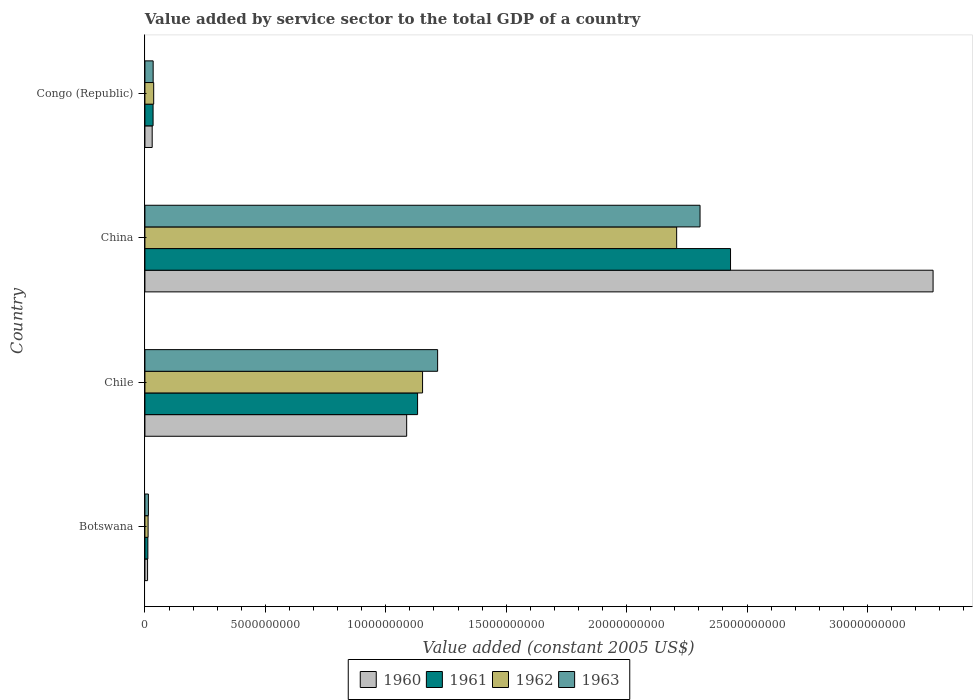Are the number of bars on each tick of the Y-axis equal?
Make the answer very short. Yes. How many bars are there on the 4th tick from the top?
Your answer should be compact. 4. How many bars are there on the 4th tick from the bottom?
Your answer should be compact. 4. What is the label of the 4th group of bars from the top?
Make the answer very short. Botswana. What is the value added by service sector in 1962 in Chile?
Make the answer very short. 1.15e+1. Across all countries, what is the maximum value added by service sector in 1962?
Ensure brevity in your answer.  2.21e+1. Across all countries, what is the minimum value added by service sector in 1961?
Your answer should be very brief. 1.22e+08. In which country was the value added by service sector in 1960 minimum?
Ensure brevity in your answer.  Botswana. What is the total value added by service sector in 1963 in the graph?
Provide a short and direct response. 3.57e+1. What is the difference between the value added by service sector in 1961 in China and that in Congo (Republic)?
Your response must be concise. 2.40e+1. What is the difference between the value added by service sector in 1963 in Botswana and the value added by service sector in 1962 in China?
Ensure brevity in your answer.  -2.19e+1. What is the average value added by service sector in 1962 per country?
Ensure brevity in your answer.  8.52e+09. What is the difference between the value added by service sector in 1962 and value added by service sector in 1963 in Botswana?
Provide a short and direct response. -1.28e+07. In how many countries, is the value added by service sector in 1963 greater than 25000000000 US$?
Your response must be concise. 0. What is the ratio of the value added by service sector in 1963 in Chile to that in China?
Keep it short and to the point. 0.53. Is the value added by service sector in 1963 in Chile less than that in China?
Ensure brevity in your answer.  Yes. Is the difference between the value added by service sector in 1962 in Botswana and China greater than the difference between the value added by service sector in 1963 in Botswana and China?
Offer a very short reply. Yes. What is the difference between the highest and the second highest value added by service sector in 1962?
Ensure brevity in your answer.  1.05e+1. What is the difference between the highest and the lowest value added by service sector in 1963?
Provide a succinct answer. 2.29e+1. Is the sum of the value added by service sector in 1963 in Chile and China greater than the maximum value added by service sector in 1961 across all countries?
Make the answer very short. Yes. How many bars are there?
Ensure brevity in your answer.  16. Are all the bars in the graph horizontal?
Offer a very short reply. Yes. How many countries are there in the graph?
Your response must be concise. 4. Does the graph contain any zero values?
Provide a succinct answer. No. Does the graph contain grids?
Provide a short and direct response. No. What is the title of the graph?
Give a very brief answer. Value added by service sector to the total GDP of a country. What is the label or title of the X-axis?
Your answer should be very brief. Value added (constant 2005 US$). What is the Value added (constant 2005 US$) of 1960 in Botswana?
Provide a succinct answer. 1.11e+08. What is the Value added (constant 2005 US$) of 1961 in Botswana?
Make the answer very short. 1.22e+08. What is the Value added (constant 2005 US$) of 1962 in Botswana?
Keep it short and to the point. 1.32e+08. What is the Value added (constant 2005 US$) of 1963 in Botswana?
Provide a short and direct response. 1.45e+08. What is the Value added (constant 2005 US$) in 1960 in Chile?
Offer a very short reply. 1.09e+1. What is the Value added (constant 2005 US$) in 1961 in Chile?
Ensure brevity in your answer.  1.13e+1. What is the Value added (constant 2005 US$) in 1962 in Chile?
Your response must be concise. 1.15e+1. What is the Value added (constant 2005 US$) of 1963 in Chile?
Offer a very short reply. 1.22e+1. What is the Value added (constant 2005 US$) in 1960 in China?
Your answer should be compact. 3.27e+1. What is the Value added (constant 2005 US$) in 1961 in China?
Provide a succinct answer. 2.43e+1. What is the Value added (constant 2005 US$) of 1962 in China?
Your answer should be very brief. 2.21e+1. What is the Value added (constant 2005 US$) of 1963 in China?
Provide a short and direct response. 2.30e+1. What is the Value added (constant 2005 US$) in 1960 in Congo (Republic)?
Your answer should be very brief. 3.02e+08. What is the Value added (constant 2005 US$) in 1961 in Congo (Republic)?
Your answer should be compact. 3.39e+08. What is the Value added (constant 2005 US$) of 1962 in Congo (Republic)?
Offer a terse response. 3.64e+08. What is the Value added (constant 2005 US$) of 1963 in Congo (Republic)?
Give a very brief answer. 3.42e+08. Across all countries, what is the maximum Value added (constant 2005 US$) of 1960?
Keep it short and to the point. 3.27e+1. Across all countries, what is the maximum Value added (constant 2005 US$) of 1961?
Offer a very short reply. 2.43e+1. Across all countries, what is the maximum Value added (constant 2005 US$) of 1962?
Your response must be concise. 2.21e+1. Across all countries, what is the maximum Value added (constant 2005 US$) of 1963?
Offer a very short reply. 2.30e+1. Across all countries, what is the minimum Value added (constant 2005 US$) in 1960?
Provide a succinct answer. 1.11e+08. Across all countries, what is the minimum Value added (constant 2005 US$) of 1961?
Offer a very short reply. 1.22e+08. Across all countries, what is the minimum Value added (constant 2005 US$) in 1962?
Make the answer very short. 1.32e+08. Across all countries, what is the minimum Value added (constant 2005 US$) in 1963?
Give a very brief answer. 1.45e+08. What is the total Value added (constant 2005 US$) in 1960 in the graph?
Your response must be concise. 4.40e+1. What is the total Value added (constant 2005 US$) in 1961 in the graph?
Provide a short and direct response. 3.61e+1. What is the total Value added (constant 2005 US$) in 1962 in the graph?
Offer a very short reply. 3.41e+1. What is the total Value added (constant 2005 US$) of 1963 in the graph?
Your answer should be very brief. 3.57e+1. What is the difference between the Value added (constant 2005 US$) in 1960 in Botswana and that in Chile?
Your answer should be compact. -1.08e+1. What is the difference between the Value added (constant 2005 US$) in 1961 in Botswana and that in Chile?
Your answer should be compact. -1.12e+1. What is the difference between the Value added (constant 2005 US$) of 1962 in Botswana and that in Chile?
Your answer should be very brief. -1.14e+1. What is the difference between the Value added (constant 2005 US$) in 1963 in Botswana and that in Chile?
Make the answer very short. -1.20e+1. What is the difference between the Value added (constant 2005 US$) of 1960 in Botswana and that in China?
Provide a short and direct response. -3.26e+1. What is the difference between the Value added (constant 2005 US$) of 1961 in Botswana and that in China?
Give a very brief answer. -2.42e+1. What is the difference between the Value added (constant 2005 US$) in 1962 in Botswana and that in China?
Provide a succinct answer. -2.19e+1. What is the difference between the Value added (constant 2005 US$) in 1963 in Botswana and that in China?
Provide a short and direct response. -2.29e+1. What is the difference between the Value added (constant 2005 US$) of 1960 in Botswana and that in Congo (Republic)?
Keep it short and to the point. -1.91e+08. What is the difference between the Value added (constant 2005 US$) in 1961 in Botswana and that in Congo (Republic)?
Provide a succinct answer. -2.17e+08. What is the difference between the Value added (constant 2005 US$) of 1962 in Botswana and that in Congo (Republic)?
Ensure brevity in your answer.  -2.32e+08. What is the difference between the Value added (constant 2005 US$) in 1963 in Botswana and that in Congo (Republic)?
Offer a terse response. -1.97e+08. What is the difference between the Value added (constant 2005 US$) in 1960 in Chile and that in China?
Make the answer very short. -2.19e+1. What is the difference between the Value added (constant 2005 US$) of 1961 in Chile and that in China?
Your answer should be very brief. -1.30e+1. What is the difference between the Value added (constant 2005 US$) in 1962 in Chile and that in China?
Your answer should be compact. -1.05e+1. What is the difference between the Value added (constant 2005 US$) of 1963 in Chile and that in China?
Your response must be concise. -1.09e+1. What is the difference between the Value added (constant 2005 US$) of 1960 in Chile and that in Congo (Republic)?
Make the answer very short. 1.06e+1. What is the difference between the Value added (constant 2005 US$) in 1961 in Chile and that in Congo (Republic)?
Your answer should be very brief. 1.10e+1. What is the difference between the Value added (constant 2005 US$) of 1962 in Chile and that in Congo (Republic)?
Provide a short and direct response. 1.12e+1. What is the difference between the Value added (constant 2005 US$) of 1963 in Chile and that in Congo (Republic)?
Keep it short and to the point. 1.18e+1. What is the difference between the Value added (constant 2005 US$) in 1960 in China and that in Congo (Republic)?
Make the answer very short. 3.24e+1. What is the difference between the Value added (constant 2005 US$) of 1961 in China and that in Congo (Republic)?
Your answer should be very brief. 2.40e+1. What is the difference between the Value added (constant 2005 US$) in 1962 in China and that in Congo (Republic)?
Your answer should be very brief. 2.17e+1. What is the difference between the Value added (constant 2005 US$) of 1963 in China and that in Congo (Republic)?
Ensure brevity in your answer.  2.27e+1. What is the difference between the Value added (constant 2005 US$) of 1960 in Botswana and the Value added (constant 2005 US$) of 1961 in Chile?
Your answer should be compact. -1.12e+1. What is the difference between the Value added (constant 2005 US$) in 1960 in Botswana and the Value added (constant 2005 US$) in 1962 in Chile?
Your answer should be very brief. -1.14e+1. What is the difference between the Value added (constant 2005 US$) of 1960 in Botswana and the Value added (constant 2005 US$) of 1963 in Chile?
Ensure brevity in your answer.  -1.20e+1. What is the difference between the Value added (constant 2005 US$) of 1961 in Botswana and the Value added (constant 2005 US$) of 1962 in Chile?
Offer a very short reply. -1.14e+1. What is the difference between the Value added (constant 2005 US$) of 1961 in Botswana and the Value added (constant 2005 US$) of 1963 in Chile?
Your response must be concise. -1.20e+1. What is the difference between the Value added (constant 2005 US$) in 1962 in Botswana and the Value added (constant 2005 US$) in 1963 in Chile?
Ensure brevity in your answer.  -1.20e+1. What is the difference between the Value added (constant 2005 US$) in 1960 in Botswana and the Value added (constant 2005 US$) in 1961 in China?
Ensure brevity in your answer.  -2.42e+1. What is the difference between the Value added (constant 2005 US$) in 1960 in Botswana and the Value added (constant 2005 US$) in 1962 in China?
Your answer should be very brief. -2.20e+1. What is the difference between the Value added (constant 2005 US$) in 1960 in Botswana and the Value added (constant 2005 US$) in 1963 in China?
Make the answer very short. -2.29e+1. What is the difference between the Value added (constant 2005 US$) of 1961 in Botswana and the Value added (constant 2005 US$) of 1962 in China?
Give a very brief answer. -2.20e+1. What is the difference between the Value added (constant 2005 US$) of 1961 in Botswana and the Value added (constant 2005 US$) of 1963 in China?
Your response must be concise. -2.29e+1. What is the difference between the Value added (constant 2005 US$) in 1962 in Botswana and the Value added (constant 2005 US$) in 1963 in China?
Give a very brief answer. -2.29e+1. What is the difference between the Value added (constant 2005 US$) of 1960 in Botswana and the Value added (constant 2005 US$) of 1961 in Congo (Republic)?
Give a very brief answer. -2.28e+08. What is the difference between the Value added (constant 2005 US$) in 1960 in Botswana and the Value added (constant 2005 US$) in 1962 in Congo (Republic)?
Provide a succinct answer. -2.53e+08. What is the difference between the Value added (constant 2005 US$) in 1960 in Botswana and the Value added (constant 2005 US$) in 1963 in Congo (Republic)?
Your answer should be very brief. -2.31e+08. What is the difference between the Value added (constant 2005 US$) in 1961 in Botswana and the Value added (constant 2005 US$) in 1962 in Congo (Republic)?
Keep it short and to the point. -2.42e+08. What is the difference between the Value added (constant 2005 US$) in 1961 in Botswana and the Value added (constant 2005 US$) in 1963 in Congo (Republic)?
Your answer should be very brief. -2.20e+08. What is the difference between the Value added (constant 2005 US$) of 1962 in Botswana and the Value added (constant 2005 US$) of 1963 in Congo (Republic)?
Provide a succinct answer. -2.10e+08. What is the difference between the Value added (constant 2005 US$) of 1960 in Chile and the Value added (constant 2005 US$) of 1961 in China?
Your response must be concise. -1.34e+1. What is the difference between the Value added (constant 2005 US$) in 1960 in Chile and the Value added (constant 2005 US$) in 1962 in China?
Keep it short and to the point. -1.12e+1. What is the difference between the Value added (constant 2005 US$) in 1960 in Chile and the Value added (constant 2005 US$) in 1963 in China?
Your answer should be very brief. -1.22e+1. What is the difference between the Value added (constant 2005 US$) of 1961 in Chile and the Value added (constant 2005 US$) of 1962 in China?
Keep it short and to the point. -1.08e+1. What is the difference between the Value added (constant 2005 US$) of 1961 in Chile and the Value added (constant 2005 US$) of 1963 in China?
Your answer should be compact. -1.17e+1. What is the difference between the Value added (constant 2005 US$) of 1962 in Chile and the Value added (constant 2005 US$) of 1963 in China?
Give a very brief answer. -1.15e+1. What is the difference between the Value added (constant 2005 US$) in 1960 in Chile and the Value added (constant 2005 US$) in 1961 in Congo (Republic)?
Offer a terse response. 1.05e+1. What is the difference between the Value added (constant 2005 US$) in 1960 in Chile and the Value added (constant 2005 US$) in 1962 in Congo (Republic)?
Provide a short and direct response. 1.05e+1. What is the difference between the Value added (constant 2005 US$) of 1960 in Chile and the Value added (constant 2005 US$) of 1963 in Congo (Republic)?
Your response must be concise. 1.05e+1. What is the difference between the Value added (constant 2005 US$) of 1961 in Chile and the Value added (constant 2005 US$) of 1962 in Congo (Republic)?
Make the answer very short. 1.10e+1. What is the difference between the Value added (constant 2005 US$) of 1961 in Chile and the Value added (constant 2005 US$) of 1963 in Congo (Republic)?
Provide a short and direct response. 1.10e+1. What is the difference between the Value added (constant 2005 US$) in 1962 in Chile and the Value added (constant 2005 US$) in 1963 in Congo (Republic)?
Offer a terse response. 1.12e+1. What is the difference between the Value added (constant 2005 US$) of 1960 in China and the Value added (constant 2005 US$) of 1961 in Congo (Republic)?
Your response must be concise. 3.24e+1. What is the difference between the Value added (constant 2005 US$) in 1960 in China and the Value added (constant 2005 US$) in 1962 in Congo (Republic)?
Offer a terse response. 3.24e+1. What is the difference between the Value added (constant 2005 US$) of 1960 in China and the Value added (constant 2005 US$) of 1963 in Congo (Republic)?
Ensure brevity in your answer.  3.24e+1. What is the difference between the Value added (constant 2005 US$) in 1961 in China and the Value added (constant 2005 US$) in 1962 in Congo (Republic)?
Offer a terse response. 2.39e+1. What is the difference between the Value added (constant 2005 US$) of 1961 in China and the Value added (constant 2005 US$) of 1963 in Congo (Republic)?
Ensure brevity in your answer.  2.40e+1. What is the difference between the Value added (constant 2005 US$) in 1962 in China and the Value added (constant 2005 US$) in 1963 in Congo (Republic)?
Your answer should be compact. 2.17e+1. What is the average Value added (constant 2005 US$) of 1960 per country?
Provide a short and direct response. 1.10e+1. What is the average Value added (constant 2005 US$) in 1961 per country?
Your answer should be very brief. 9.02e+09. What is the average Value added (constant 2005 US$) in 1962 per country?
Your answer should be compact. 8.52e+09. What is the average Value added (constant 2005 US$) in 1963 per country?
Your answer should be very brief. 8.92e+09. What is the difference between the Value added (constant 2005 US$) of 1960 and Value added (constant 2005 US$) of 1961 in Botswana?
Your answer should be very brief. -1.12e+07. What is the difference between the Value added (constant 2005 US$) in 1960 and Value added (constant 2005 US$) in 1962 in Botswana?
Offer a terse response. -2.17e+07. What is the difference between the Value added (constant 2005 US$) in 1960 and Value added (constant 2005 US$) in 1963 in Botswana?
Give a very brief answer. -3.45e+07. What is the difference between the Value added (constant 2005 US$) of 1961 and Value added (constant 2005 US$) of 1962 in Botswana?
Offer a terse response. -1.05e+07. What is the difference between the Value added (constant 2005 US$) in 1961 and Value added (constant 2005 US$) in 1963 in Botswana?
Keep it short and to the point. -2.33e+07. What is the difference between the Value added (constant 2005 US$) in 1962 and Value added (constant 2005 US$) in 1963 in Botswana?
Provide a succinct answer. -1.28e+07. What is the difference between the Value added (constant 2005 US$) of 1960 and Value added (constant 2005 US$) of 1961 in Chile?
Offer a very short reply. -4.53e+08. What is the difference between the Value added (constant 2005 US$) in 1960 and Value added (constant 2005 US$) in 1962 in Chile?
Give a very brief answer. -6.60e+08. What is the difference between the Value added (constant 2005 US$) of 1960 and Value added (constant 2005 US$) of 1963 in Chile?
Provide a short and direct response. -1.29e+09. What is the difference between the Value added (constant 2005 US$) in 1961 and Value added (constant 2005 US$) in 1962 in Chile?
Provide a succinct answer. -2.07e+08. What is the difference between the Value added (constant 2005 US$) in 1961 and Value added (constant 2005 US$) in 1963 in Chile?
Provide a short and direct response. -8.32e+08. What is the difference between the Value added (constant 2005 US$) of 1962 and Value added (constant 2005 US$) of 1963 in Chile?
Keep it short and to the point. -6.25e+08. What is the difference between the Value added (constant 2005 US$) in 1960 and Value added (constant 2005 US$) in 1961 in China?
Offer a very short reply. 8.41e+09. What is the difference between the Value added (constant 2005 US$) in 1960 and Value added (constant 2005 US$) in 1962 in China?
Provide a succinct answer. 1.06e+1. What is the difference between the Value added (constant 2005 US$) of 1960 and Value added (constant 2005 US$) of 1963 in China?
Your answer should be compact. 9.68e+09. What is the difference between the Value added (constant 2005 US$) in 1961 and Value added (constant 2005 US$) in 1962 in China?
Provide a short and direct response. 2.24e+09. What is the difference between the Value added (constant 2005 US$) of 1961 and Value added (constant 2005 US$) of 1963 in China?
Keep it short and to the point. 1.27e+09. What is the difference between the Value added (constant 2005 US$) in 1962 and Value added (constant 2005 US$) in 1963 in China?
Your answer should be very brief. -9.71e+08. What is the difference between the Value added (constant 2005 US$) of 1960 and Value added (constant 2005 US$) of 1961 in Congo (Republic)?
Give a very brief answer. -3.74e+07. What is the difference between the Value added (constant 2005 US$) in 1960 and Value added (constant 2005 US$) in 1962 in Congo (Republic)?
Give a very brief answer. -6.23e+07. What is the difference between the Value added (constant 2005 US$) of 1960 and Value added (constant 2005 US$) of 1963 in Congo (Republic)?
Your response must be concise. -4.05e+07. What is the difference between the Value added (constant 2005 US$) in 1961 and Value added (constant 2005 US$) in 1962 in Congo (Republic)?
Ensure brevity in your answer.  -2.49e+07. What is the difference between the Value added (constant 2005 US$) of 1961 and Value added (constant 2005 US$) of 1963 in Congo (Republic)?
Provide a short and direct response. -3.09e+06. What is the difference between the Value added (constant 2005 US$) in 1962 and Value added (constant 2005 US$) in 1963 in Congo (Republic)?
Ensure brevity in your answer.  2.18e+07. What is the ratio of the Value added (constant 2005 US$) in 1960 in Botswana to that in Chile?
Your response must be concise. 0.01. What is the ratio of the Value added (constant 2005 US$) in 1961 in Botswana to that in Chile?
Ensure brevity in your answer.  0.01. What is the ratio of the Value added (constant 2005 US$) in 1962 in Botswana to that in Chile?
Make the answer very short. 0.01. What is the ratio of the Value added (constant 2005 US$) in 1963 in Botswana to that in Chile?
Offer a terse response. 0.01. What is the ratio of the Value added (constant 2005 US$) of 1960 in Botswana to that in China?
Your answer should be very brief. 0. What is the ratio of the Value added (constant 2005 US$) in 1961 in Botswana to that in China?
Offer a very short reply. 0.01. What is the ratio of the Value added (constant 2005 US$) in 1962 in Botswana to that in China?
Your response must be concise. 0.01. What is the ratio of the Value added (constant 2005 US$) in 1963 in Botswana to that in China?
Offer a very short reply. 0.01. What is the ratio of the Value added (constant 2005 US$) in 1960 in Botswana to that in Congo (Republic)?
Offer a very short reply. 0.37. What is the ratio of the Value added (constant 2005 US$) in 1961 in Botswana to that in Congo (Republic)?
Provide a succinct answer. 0.36. What is the ratio of the Value added (constant 2005 US$) in 1962 in Botswana to that in Congo (Republic)?
Your response must be concise. 0.36. What is the ratio of the Value added (constant 2005 US$) in 1963 in Botswana to that in Congo (Republic)?
Ensure brevity in your answer.  0.42. What is the ratio of the Value added (constant 2005 US$) in 1960 in Chile to that in China?
Provide a succinct answer. 0.33. What is the ratio of the Value added (constant 2005 US$) of 1961 in Chile to that in China?
Keep it short and to the point. 0.47. What is the ratio of the Value added (constant 2005 US$) in 1962 in Chile to that in China?
Make the answer very short. 0.52. What is the ratio of the Value added (constant 2005 US$) in 1963 in Chile to that in China?
Offer a terse response. 0.53. What is the ratio of the Value added (constant 2005 US$) of 1960 in Chile to that in Congo (Republic)?
Make the answer very short. 36.04. What is the ratio of the Value added (constant 2005 US$) of 1961 in Chile to that in Congo (Republic)?
Provide a short and direct response. 33.4. What is the ratio of the Value added (constant 2005 US$) of 1962 in Chile to that in Congo (Republic)?
Ensure brevity in your answer.  31.68. What is the ratio of the Value added (constant 2005 US$) in 1963 in Chile to that in Congo (Republic)?
Provide a short and direct response. 35.53. What is the ratio of the Value added (constant 2005 US$) in 1960 in China to that in Congo (Republic)?
Ensure brevity in your answer.  108.51. What is the ratio of the Value added (constant 2005 US$) in 1961 in China to that in Congo (Republic)?
Your answer should be very brief. 71.73. What is the ratio of the Value added (constant 2005 US$) of 1962 in China to that in Congo (Republic)?
Provide a succinct answer. 60.67. What is the ratio of the Value added (constant 2005 US$) in 1963 in China to that in Congo (Republic)?
Keep it short and to the point. 67.39. What is the difference between the highest and the second highest Value added (constant 2005 US$) of 1960?
Provide a short and direct response. 2.19e+1. What is the difference between the highest and the second highest Value added (constant 2005 US$) of 1961?
Provide a short and direct response. 1.30e+1. What is the difference between the highest and the second highest Value added (constant 2005 US$) in 1962?
Offer a very short reply. 1.05e+1. What is the difference between the highest and the second highest Value added (constant 2005 US$) of 1963?
Provide a short and direct response. 1.09e+1. What is the difference between the highest and the lowest Value added (constant 2005 US$) in 1960?
Your response must be concise. 3.26e+1. What is the difference between the highest and the lowest Value added (constant 2005 US$) in 1961?
Provide a short and direct response. 2.42e+1. What is the difference between the highest and the lowest Value added (constant 2005 US$) in 1962?
Your answer should be very brief. 2.19e+1. What is the difference between the highest and the lowest Value added (constant 2005 US$) of 1963?
Make the answer very short. 2.29e+1. 